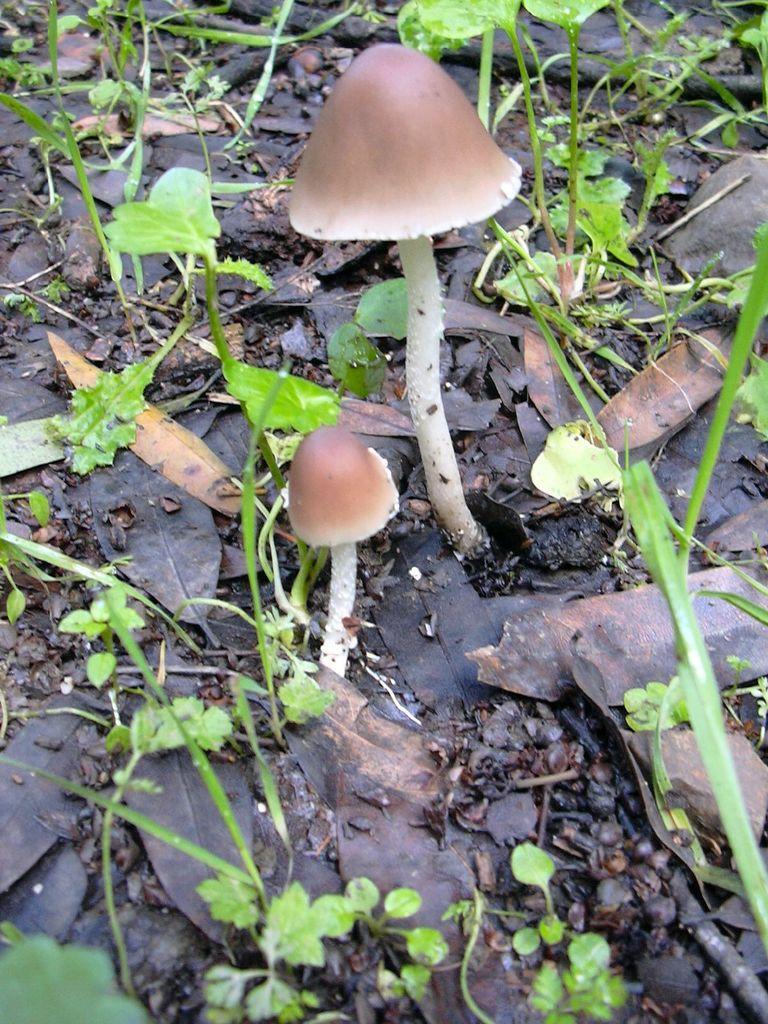How would you summarize this image in a sentence or two? In this image we can see two mushrooms, leaves, plants, sticks on the ground. 